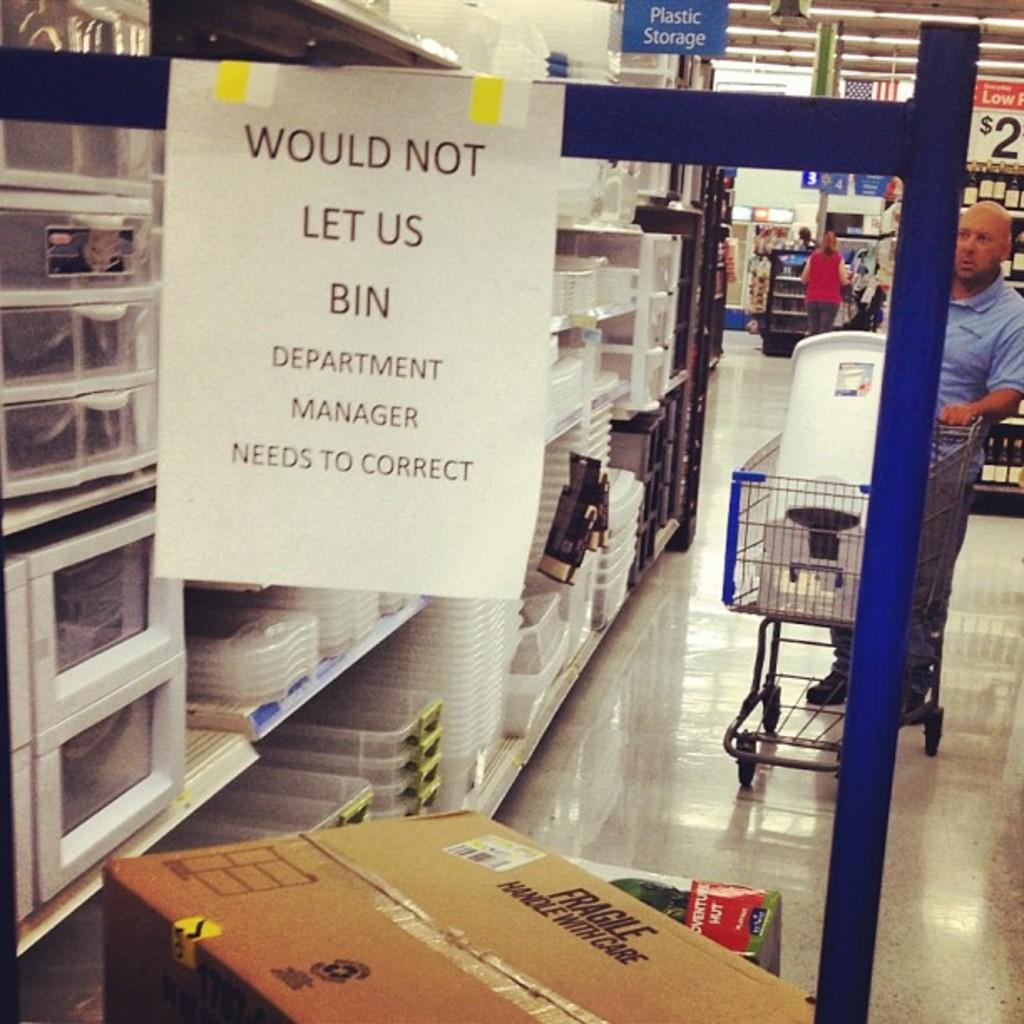<image>
Write a terse but informative summary of the picture. A sign hangs from a cart that says, "Would not let us bin." 